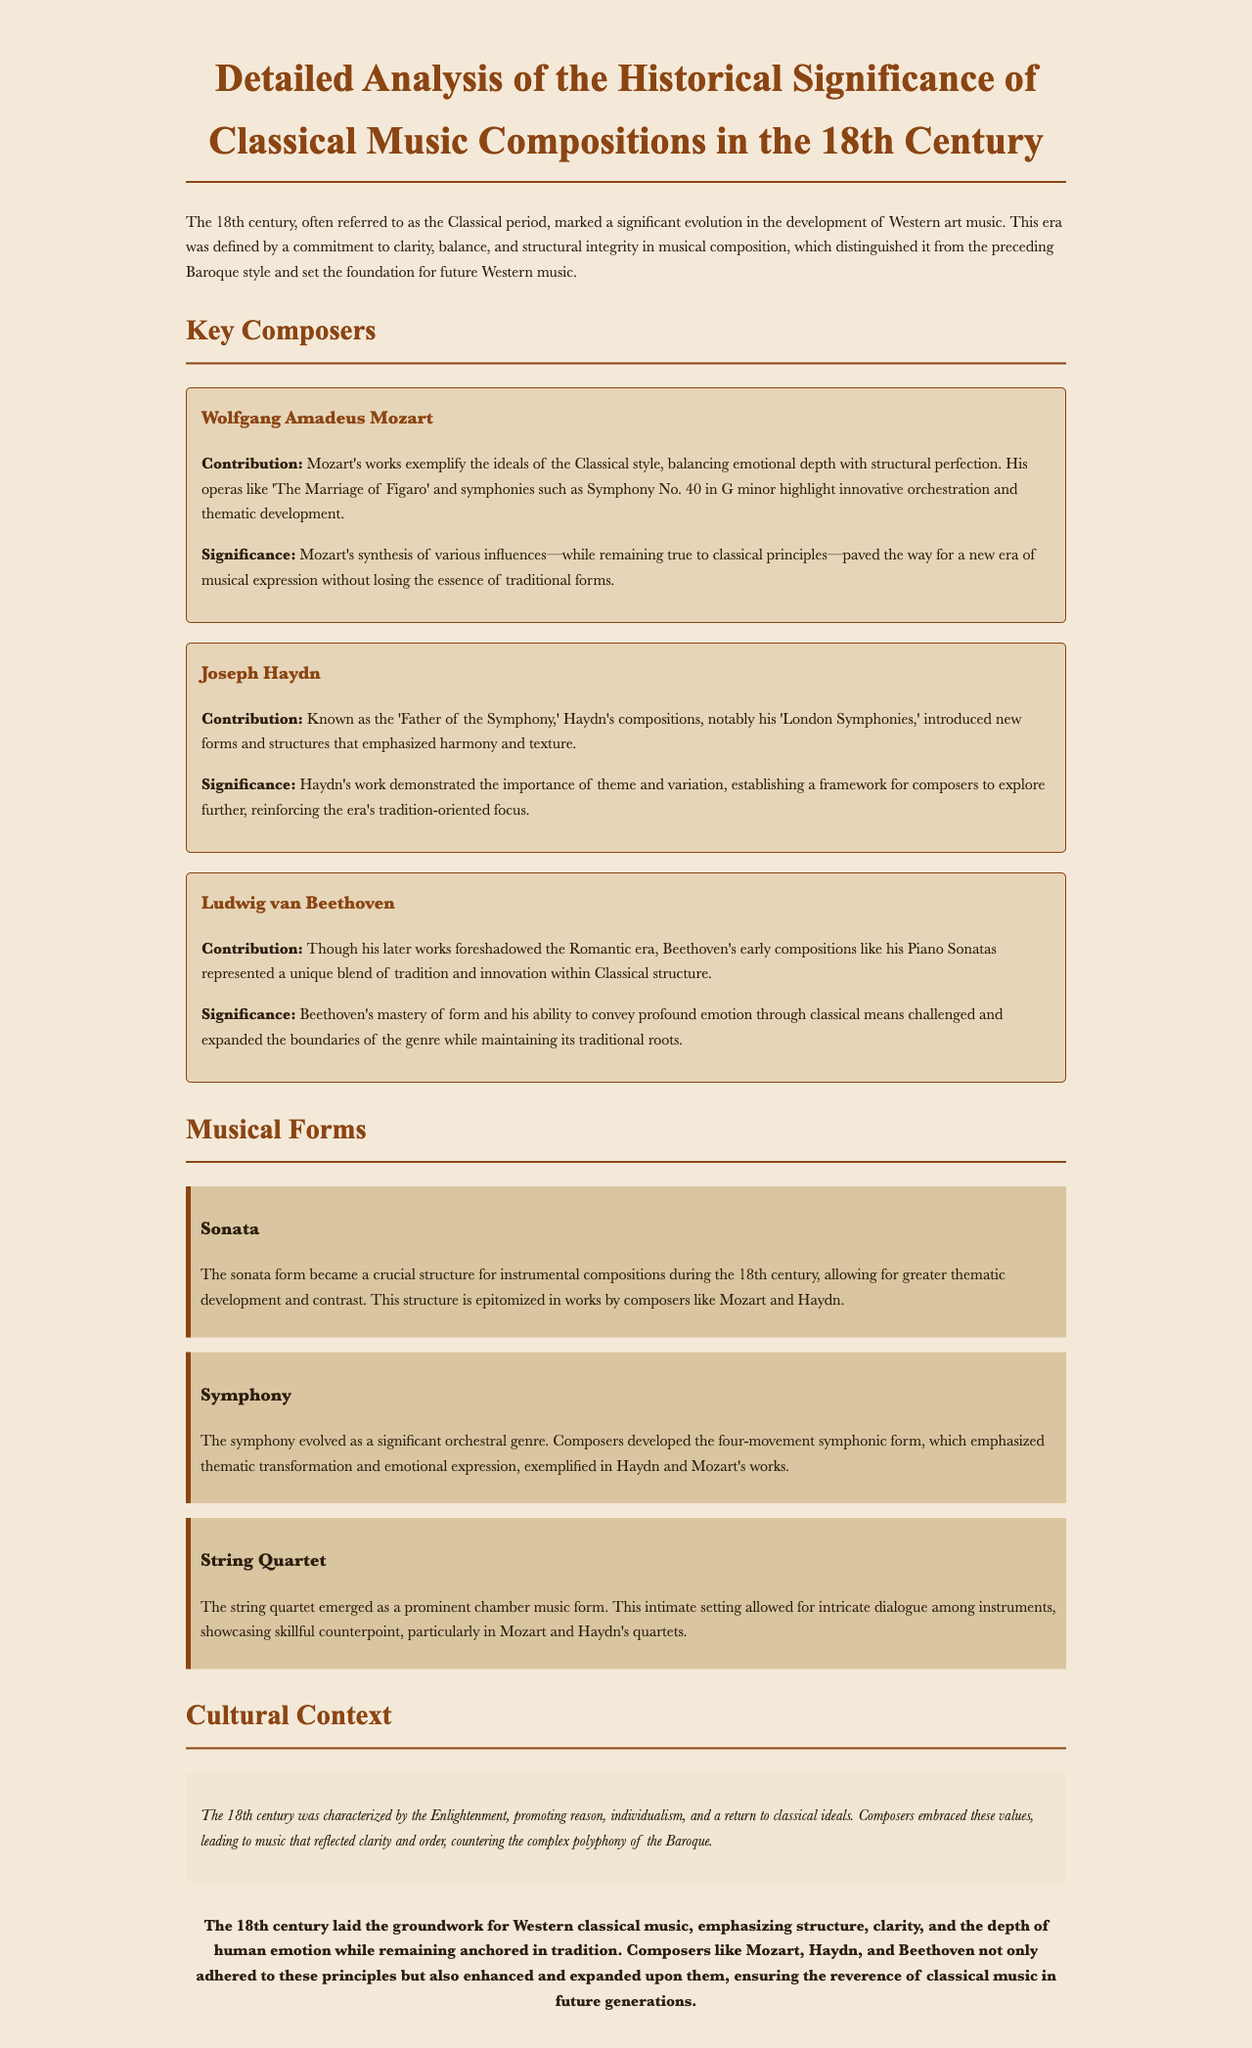What is the main title of the document? The title of the document provides the overall focus and context, which is "Detailed Analysis of the Historical Significance of Classical Music Compositions in the 18th Century."
Answer: Detailed Analysis of the Historical Significance of Classical Music Compositions in the 18th Century Who is known as the 'Father of the Symphony'? This title is specifically attributed to Joseph Haydn, as mentioned in the context of his contributions to symphonic music.
Answer: Joseph Haydn What are the three key composers discussed? These composers are highlighted in the document, showcasing their contributions to classical music in the 18th century.
Answer: Mozart, Haydn, Beethoven Which musical form became crucial for instrumental compositions? The document specifies the sonata form as a significant structure during the 18th century, essential for thematic development.
Answer: Sonata What ideology characterizes the cultural context of the 18th century? The document references the Enlightenment as a defining cultural movement during this period, influencing composers' styles and values.
Answer: Enlightenment How many movements does the four-movement symphonic form emphasize? The document emphasizes the structure of four movements, which is a hallmark of symphonic composition in this era.
Answer: Four What type of music reflects clarity and order as per the document? The document states that the music of the 18th century, defined by its clarity and order, countered the complex polyphony of the previous era.
Answer: Classical music Which two composers are particularly noted for their string quartets? The document mentions these two composers in relation to the prominence of the string quartet form in chamber music.
Answer: Mozart and Haydn 